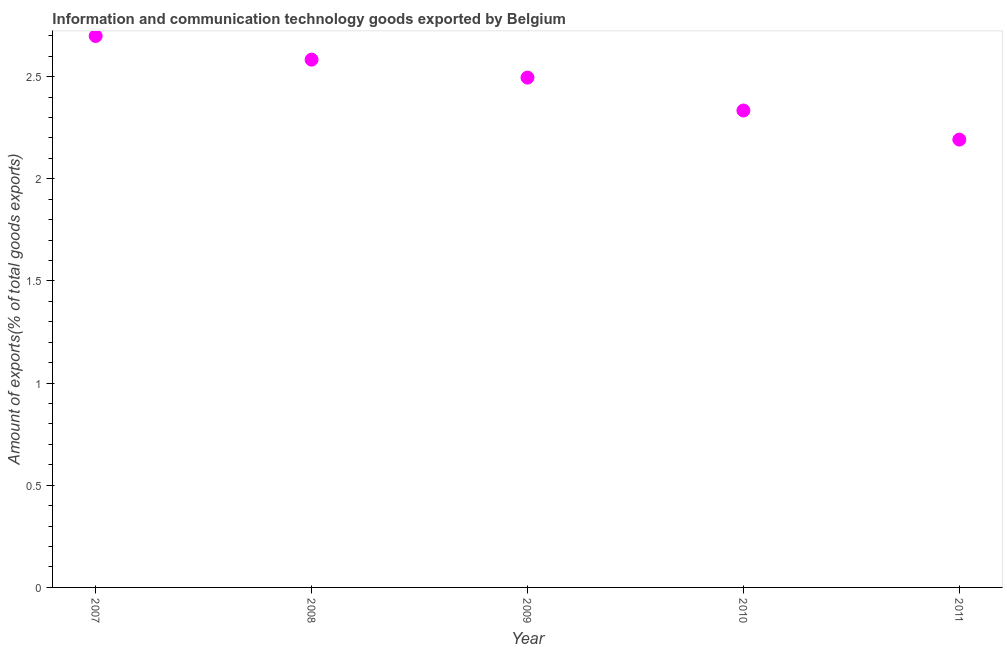What is the amount of ict goods exports in 2007?
Offer a terse response. 2.7. Across all years, what is the maximum amount of ict goods exports?
Make the answer very short. 2.7. Across all years, what is the minimum amount of ict goods exports?
Give a very brief answer. 2.19. What is the sum of the amount of ict goods exports?
Your answer should be very brief. 12.3. What is the difference between the amount of ict goods exports in 2008 and 2010?
Make the answer very short. 0.25. What is the average amount of ict goods exports per year?
Your response must be concise. 2.46. What is the median amount of ict goods exports?
Make the answer very short. 2.5. In how many years, is the amount of ict goods exports greater than 1.9 %?
Provide a succinct answer. 5. What is the ratio of the amount of ict goods exports in 2007 to that in 2011?
Offer a terse response. 1.23. Is the amount of ict goods exports in 2010 less than that in 2011?
Make the answer very short. No. What is the difference between the highest and the second highest amount of ict goods exports?
Your answer should be compact. 0.12. What is the difference between the highest and the lowest amount of ict goods exports?
Offer a terse response. 0.51. In how many years, is the amount of ict goods exports greater than the average amount of ict goods exports taken over all years?
Keep it short and to the point. 3. How many dotlines are there?
Provide a short and direct response. 1. Are the values on the major ticks of Y-axis written in scientific E-notation?
Ensure brevity in your answer.  No. What is the title of the graph?
Offer a terse response. Information and communication technology goods exported by Belgium. What is the label or title of the Y-axis?
Your answer should be very brief. Amount of exports(% of total goods exports). What is the Amount of exports(% of total goods exports) in 2007?
Keep it short and to the point. 2.7. What is the Amount of exports(% of total goods exports) in 2008?
Ensure brevity in your answer.  2.58. What is the Amount of exports(% of total goods exports) in 2009?
Your answer should be compact. 2.5. What is the Amount of exports(% of total goods exports) in 2010?
Provide a succinct answer. 2.33. What is the Amount of exports(% of total goods exports) in 2011?
Make the answer very short. 2.19. What is the difference between the Amount of exports(% of total goods exports) in 2007 and 2008?
Provide a succinct answer. 0.12. What is the difference between the Amount of exports(% of total goods exports) in 2007 and 2009?
Provide a short and direct response. 0.2. What is the difference between the Amount of exports(% of total goods exports) in 2007 and 2010?
Your answer should be compact. 0.36. What is the difference between the Amount of exports(% of total goods exports) in 2007 and 2011?
Keep it short and to the point. 0.51. What is the difference between the Amount of exports(% of total goods exports) in 2008 and 2009?
Offer a very short reply. 0.09. What is the difference between the Amount of exports(% of total goods exports) in 2008 and 2010?
Ensure brevity in your answer.  0.25. What is the difference between the Amount of exports(% of total goods exports) in 2008 and 2011?
Offer a terse response. 0.39. What is the difference between the Amount of exports(% of total goods exports) in 2009 and 2010?
Your answer should be very brief. 0.16. What is the difference between the Amount of exports(% of total goods exports) in 2009 and 2011?
Make the answer very short. 0.3. What is the difference between the Amount of exports(% of total goods exports) in 2010 and 2011?
Make the answer very short. 0.14. What is the ratio of the Amount of exports(% of total goods exports) in 2007 to that in 2008?
Provide a succinct answer. 1.04. What is the ratio of the Amount of exports(% of total goods exports) in 2007 to that in 2009?
Make the answer very short. 1.08. What is the ratio of the Amount of exports(% of total goods exports) in 2007 to that in 2010?
Your answer should be very brief. 1.16. What is the ratio of the Amount of exports(% of total goods exports) in 2007 to that in 2011?
Keep it short and to the point. 1.23. What is the ratio of the Amount of exports(% of total goods exports) in 2008 to that in 2009?
Your answer should be compact. 1.03. What is the ratio of the Amount of exports(% of total goods exports) in 2008 to that in 2010?
Provide a short and direct response. 1.11. What is the ratio of the Amount of exports(% of total goods exports) in 2008 to that in 2011?
Provide a short and direct response. 1.18. What is the ratio of the Amount of exports(% of total goods exports) in 2009 to that in 2010?
Give a very brief answer. 1.07. What is the ratio of the Amount of exports(% of total goods exports) in 2009 to that in 2011?
Provide a succinct answer. 1.14. What is the ratio of the Amount of exports(% of total goods exports) in 2010 to that in 2011?
Keep it short and to the point. 1.06. 